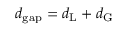<formula> <loc_0><loc_0><loc_500><loc_500>d _ { g a p } = d _ { L } + d _ { G }</formula> 